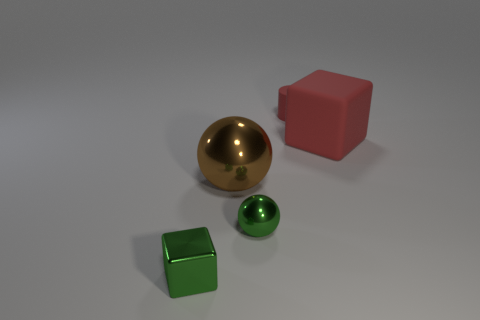What textures can be observed on each of the objects in the image? The objects exhibit a variety of textures. The large golden sphere and the small green sphere both have smooth and reflective surfaces. In contrast, the pink cube and the green cube display matte textures with little to no reflection. 